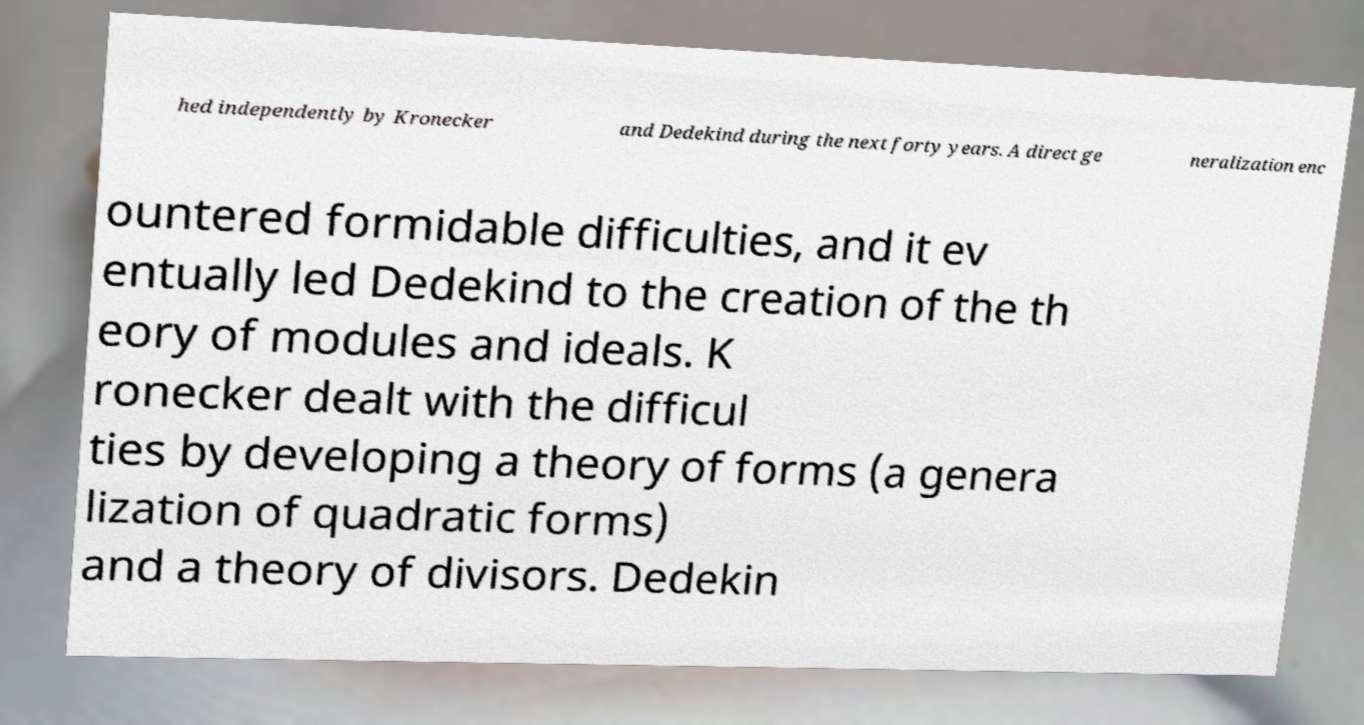Can you read and provide the text displayed in the image?This photo seems to have some interesting text. Can you extract and type it out for me? hed independently by Kronecker and Dedekind during the next forty years. A direct ge neralization enc ountered formidable difficulties, and it ev entually led Dedekind to the creation of the th eory of modules and ideals. K ronecker dealt with the difficul ties by developing a theory of forms (a genera lization of quadratic forms) and a theory of divisors. Dedekin 